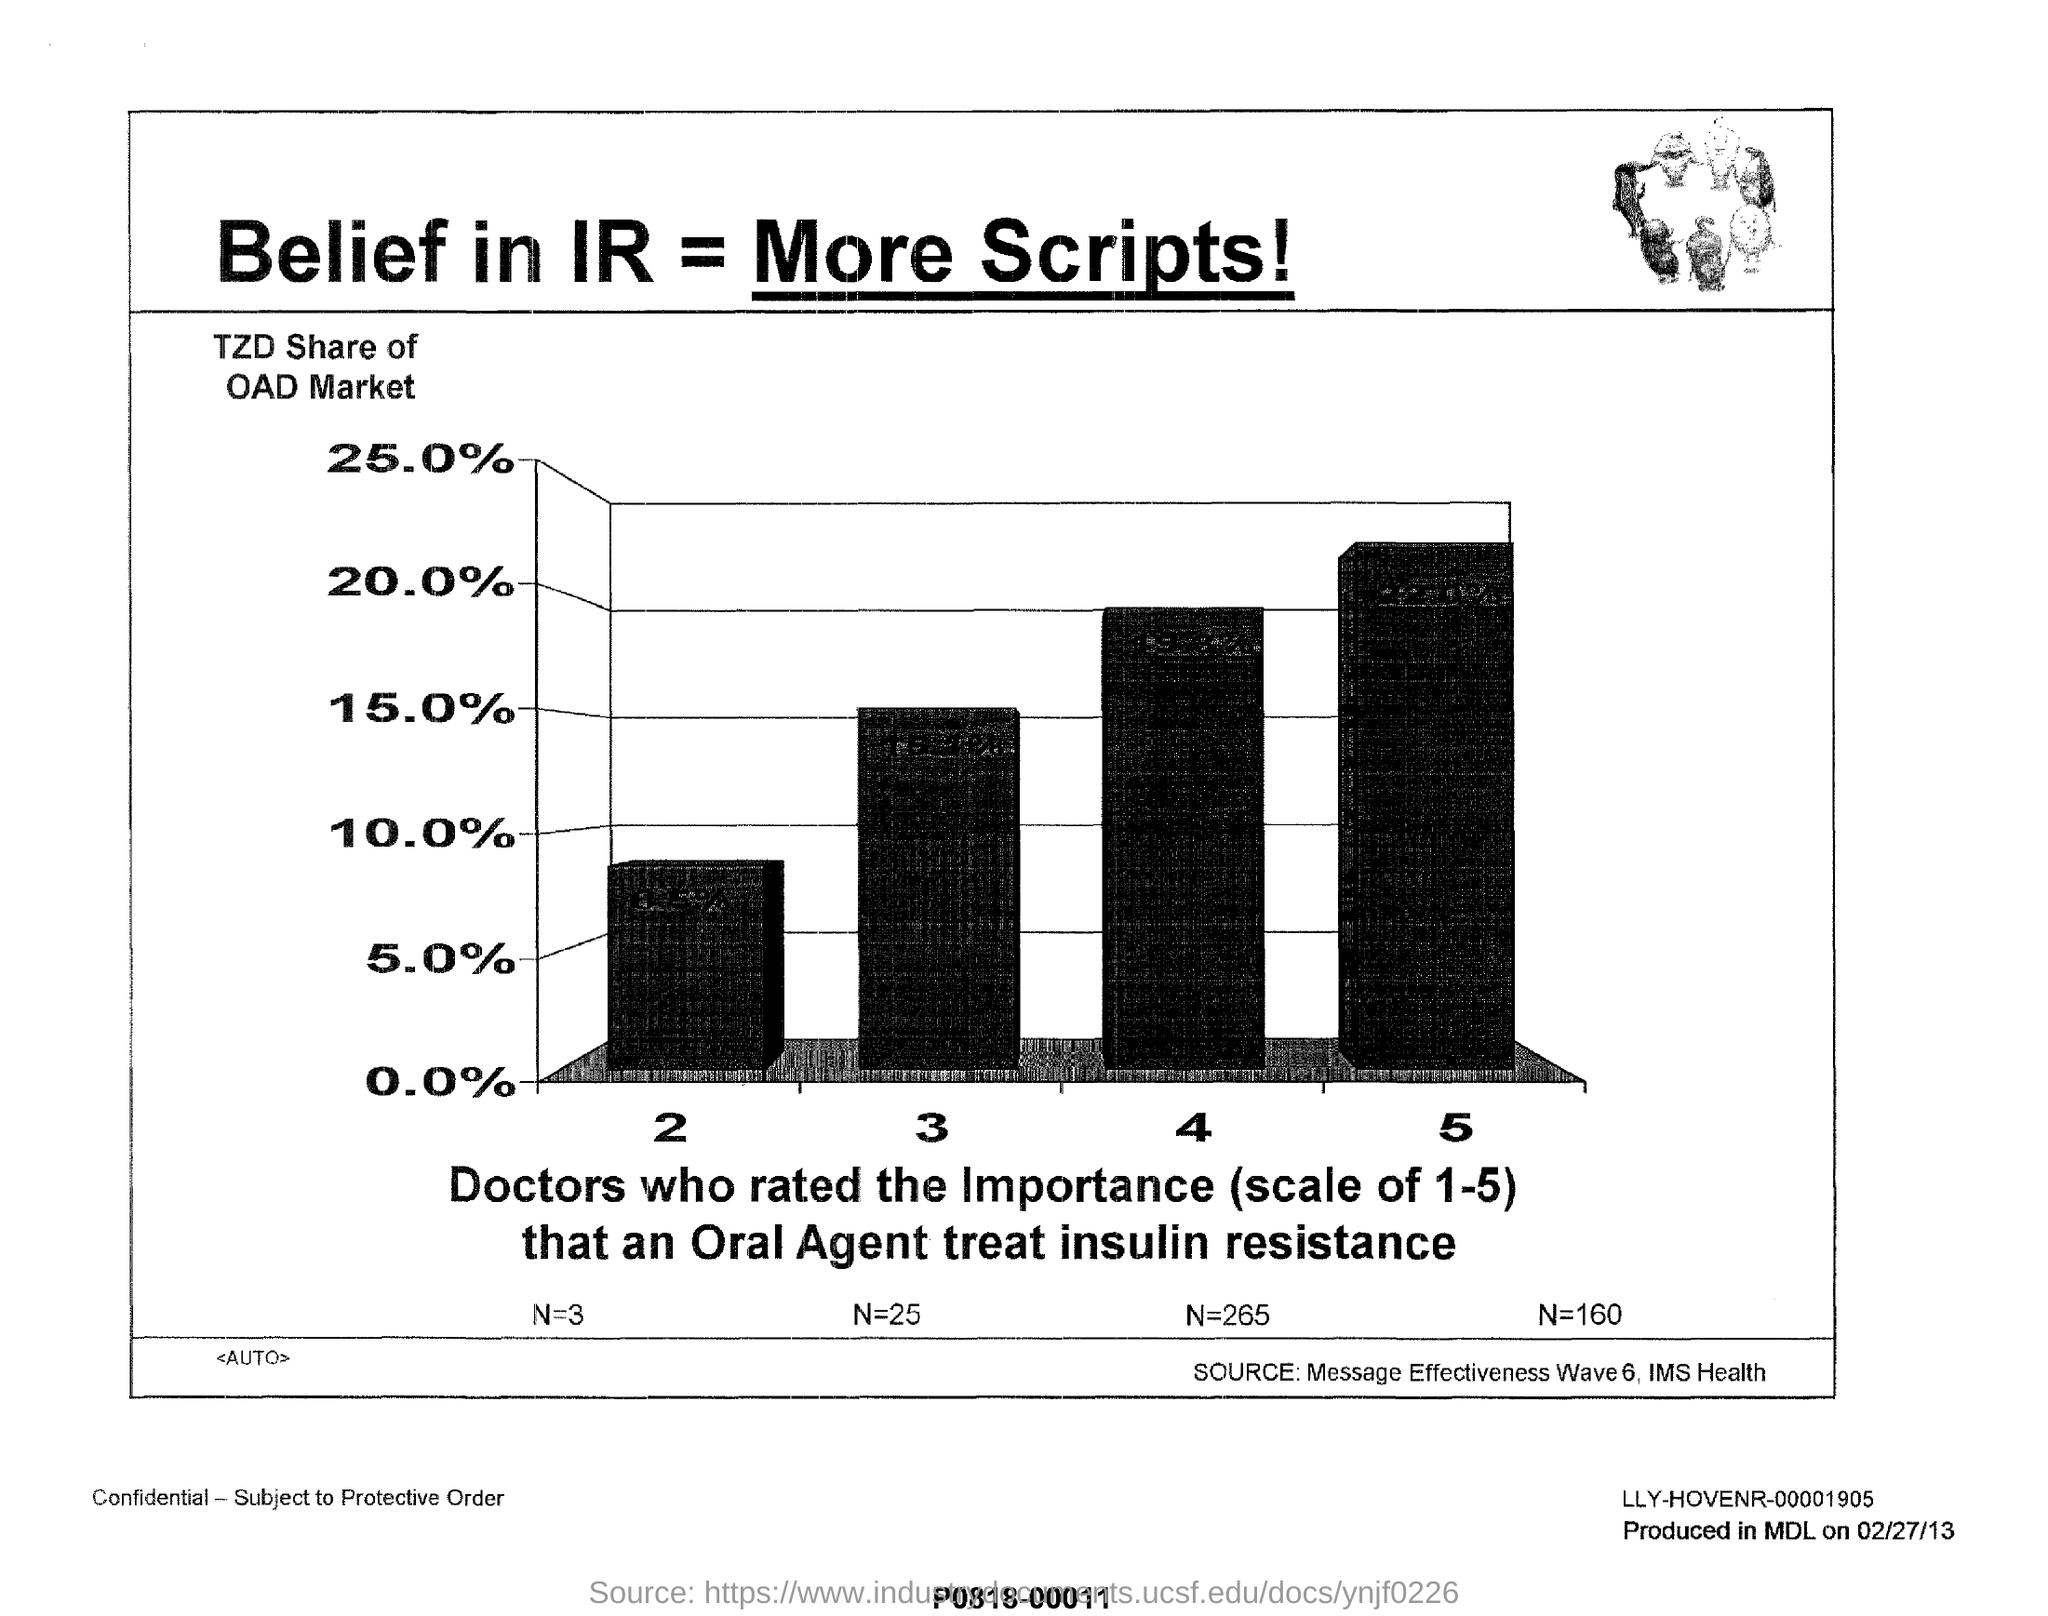What does Y- axis of the graph represent?
Keep it short and to the point. TZD share of OAD market. What percent is the TZD Share of OAD Market at the scale of 4?
Offer a very short reply. 20.0. What percent is the TZD Share of OAD Market at the scale of 3?
Offer a very short reply. 15.0. 